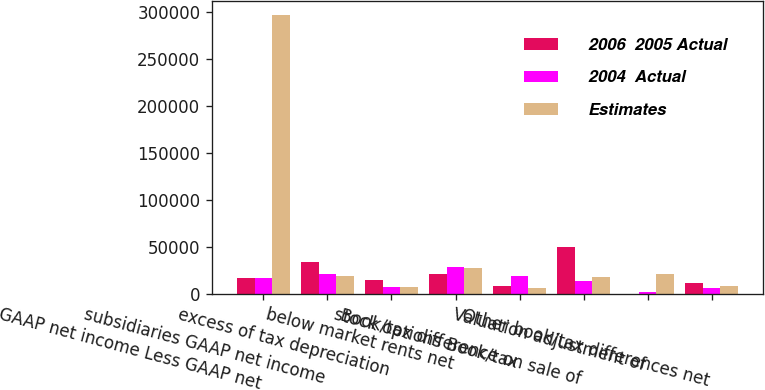<chart> <loc_0><loc_0><loc_500><loc_500><stacked_bar_chart><ecel><fcel>GAAP net income Less GAAP net<fcel>subsidiaries GAAP net income<fcel>excess of tax depreciation<fcel>below market rents net<fcel>stock options Book/tax<fcel>Book/tax difference on sale of<fcel>Valuation adjustment of<fcel>Other book/tax differences net<nl><fcel>2006  2005 Actual<fcel>17118.5<fcel>33795<fcel>15438<fcel>21994<fcel>8586<fcel>50164<fcel>142<fcel>11586<nl><fcel>2004  Actual<fcel>17118.5<fcel>21666<fcel>7398<fcel>29144<fcel>19048<fcel>14181<fcel>2537<fcel>6773<nl><fcel>Estimates<fcel>297137<fcel>19396<fcel>7200<fcel>28022<fcel>6350<fcel>18799<fcel>21697<fcel>8419<nl></chart> 